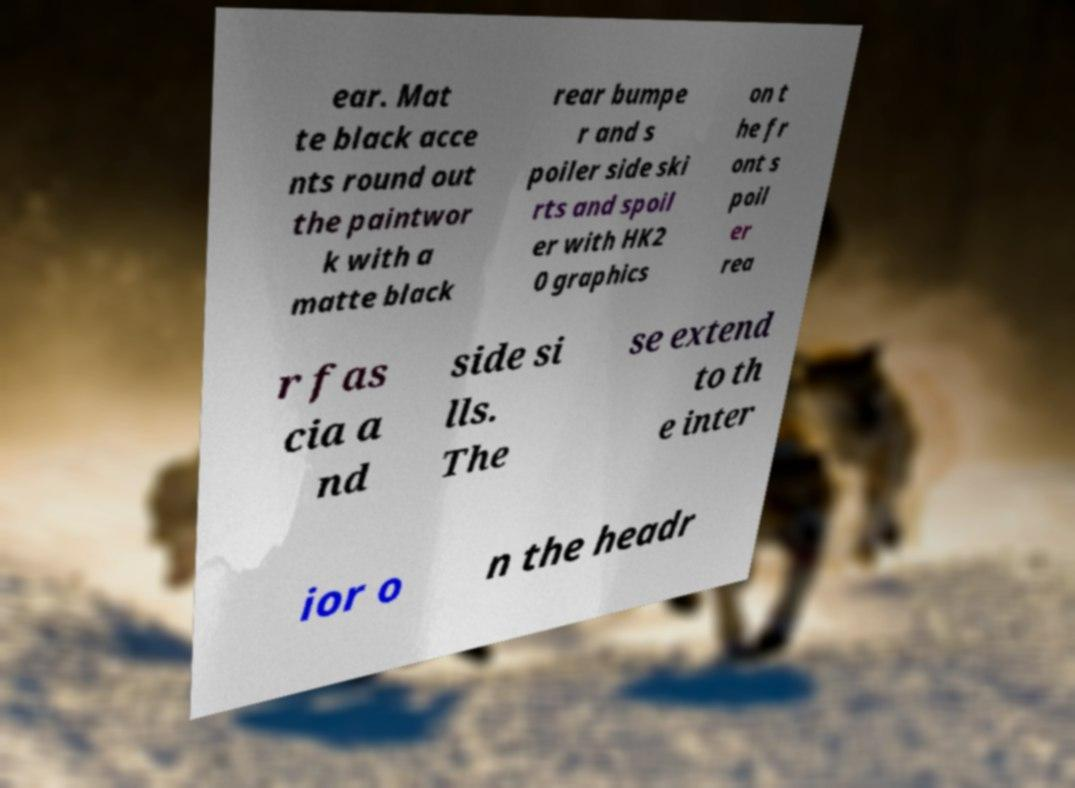Can you accurately transcribe the text from the provided image for me? ear. Mat te black acce nts round out the paintwor k with a matte black rear bumpe r and s poiler side ski rts and spoil er with HK2 0 graphics on t he fr ont s poil er rea r fas cia a nd side si lls. The se extend to th e inter ior o n the headr 